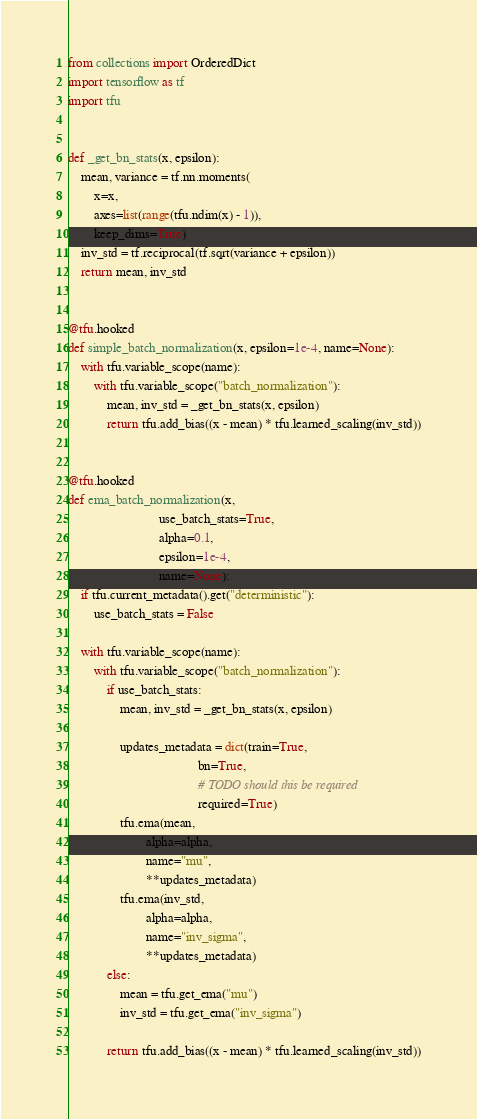Convert code to text. <code><loc_0><loc_0><loc_500><loc_500><_Python_>from collections import OrderedDict
import tensorflow as tf
import tfu


def _get_bn_stats(x, epsilon):
    mean, variance = tf.nn.moments(
        x=x,
        axes=list(range(tfu.ndim(x) - 1)),
        keep_dims=True)
    inv_std = tf.reciprocal(tf.sqrt(variance + epsilon))
    return mean, inv_std


@tfu.hooked
def simple_batch_normalization(x, epsilon=1e-4, name=None):
    with tfu.variable_scope(name):
        with tfu.variable_scope("batch_normalization"):
            mean, inv_std = _get_bn_stats(x, epsilon)
            return tfu.add_bias((x - mean) * tfu.learned_scaling(inv_std))


@tfu.hooked
def ema_batch_normalization(x,
                            use_batch_stats=True,
                            alpha=0.1,
                            epsilon=1e-4,
                            name=None):
    if tfu.current_metadata().get("deterministic"):
        use_batch_stats = False

    with tfu.variable_scope(name):
        with tfu.variable_scope("batch_normalization"):
            if use_batch_stats:
                mean, inv_std = _get_bn_stats(x, epsilon)

                updates_metadata = dict(train=True,
                                        bn=True,
                                        # TODO should this be required
                                        required=True)
                tfu.ema(mean,
                        alpha=alpha,
                        name="mu",
                        **updates_metadata)
                tfu.ema(inv_std,
                        alpha=alpha,
                        name="inv_sigma",
                        **updates_metadata)
            else:
                mean = tfu.get_ema("mu")
                inv_std = tfu.get_ema("inv_sigma")

            return tfu.add_bias((x - mean) * tfu.learned_scaling(inv_std))
</code> 